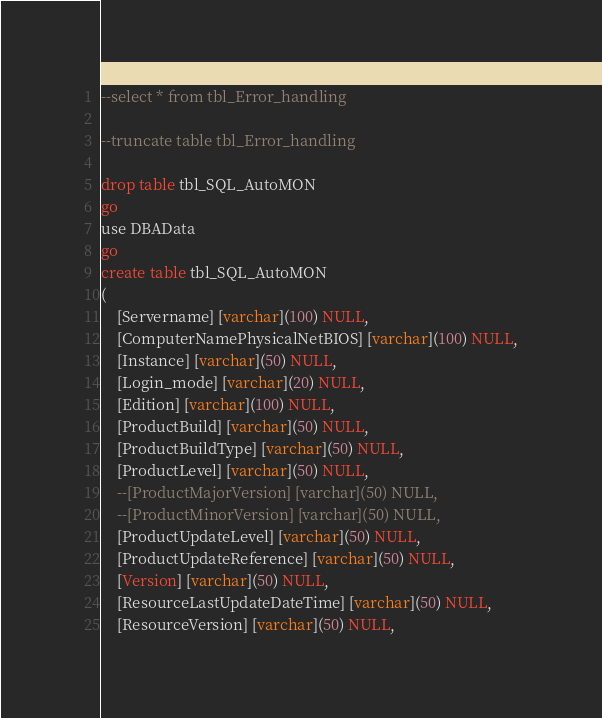Convert code to text. <code><loc_0><loc_0><loc_500><loc_500><_SQL_>
--select * from tbl_Error_handling

--truncate table tbl_Error_handling

drop table tbl_SQL_AutoMON
go
use DBAData
go
create table tbl_SQL_AutoMON
(
	[Servername] [varchar](100) NULL,
	[ComputerNamePhysicalNetBIOS] [varchar](100) NULL,
	[Instance] [varchar](50) NULL,
	[Login_mode] [varchar](20) NULL,
	[Edition] [varchar](100) NULL,
	[ProductBuild] [varchar](50) NULL,
	[ProductBuildType] [varchar](50) NULL,
	[ProductLevel] [varchar](50) NULL,
	--[ProductMajorVersion] [varchar](50) NULL,
	--[ProductMinorVersion] [varchar](50) NULL,
	[ProductUpdateLevel] [varchar](50) NULL,
	[ProductUpdateReference] [varchar](50) NULL,
	[Version] [varchar](50) NULL,
	[ResourceLastUpdateDateTime] [varchar](50) NULL,
	[ResourceVersion] [varchar](50) NULL,</code> 